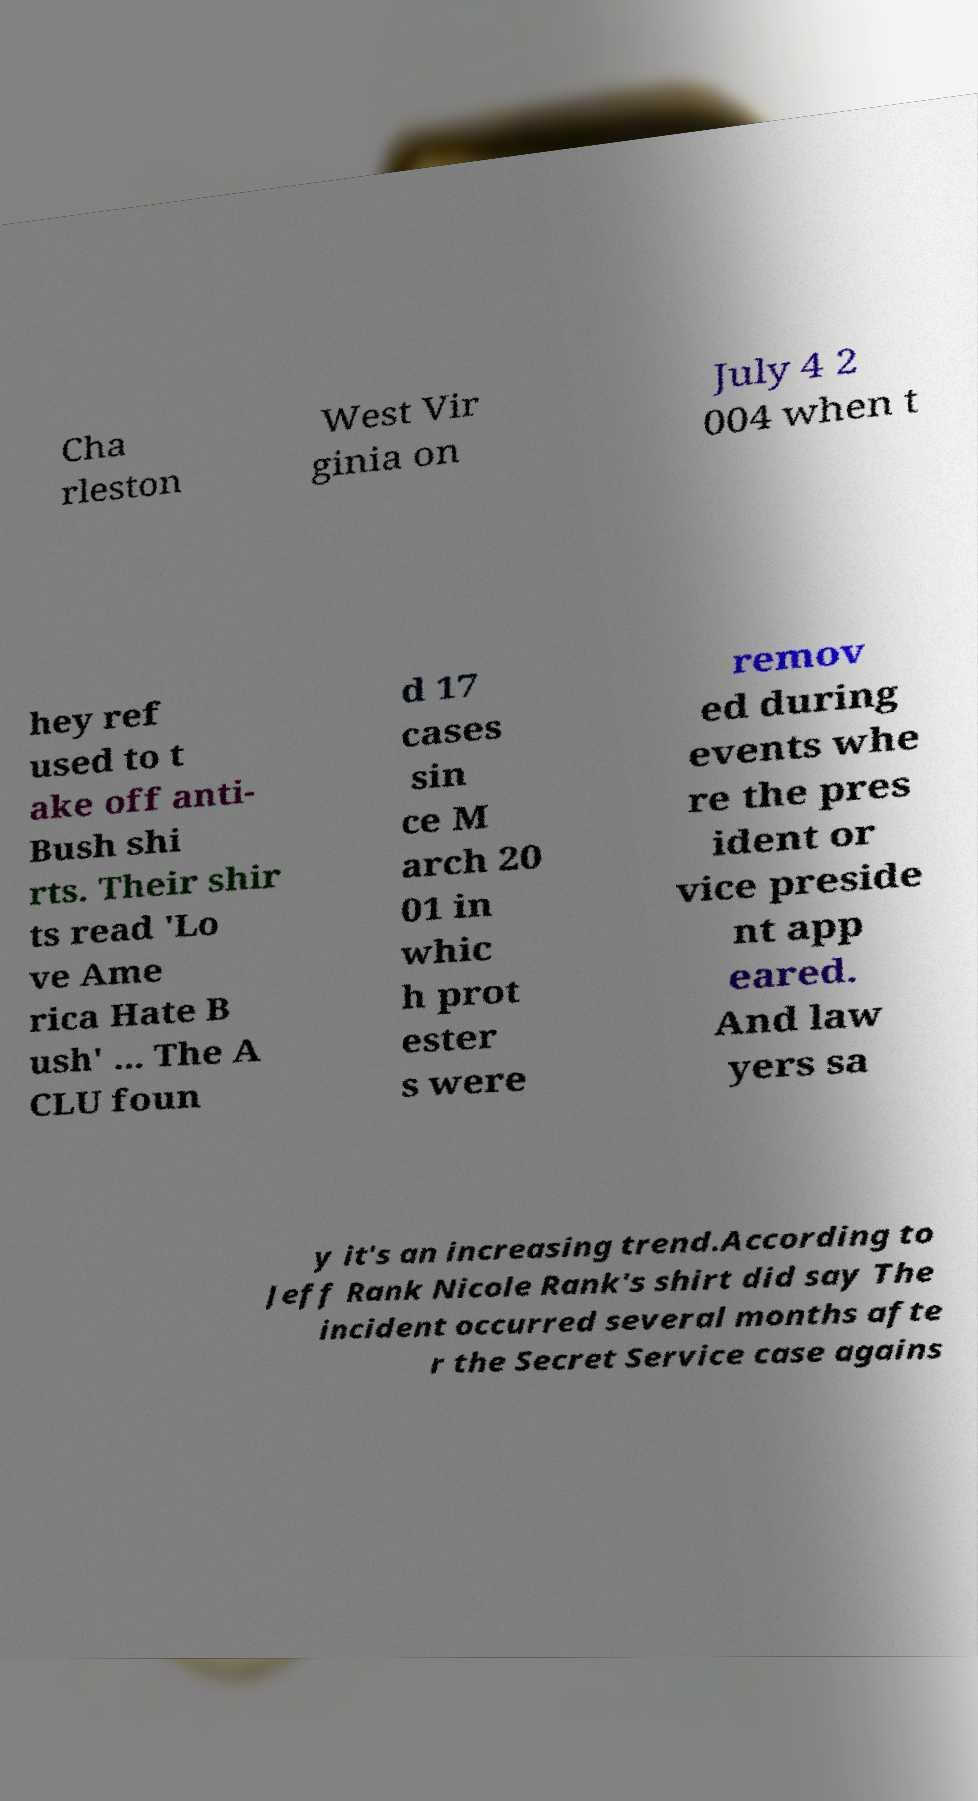What messages or text are displayed in this image? I need them in a readable, typed format. Cha rleston West Vir ginia on July 4 2 004 when t hey ref used to t ake off anti- Bush shi rts. Their shir ts read 'Lo ve Ame rica Hate B ush' ... The A CLU foun d 17 cases sin ce M arch 20 01 in whic h prot ester s were remov ed during events whe re the pres ident or vice preside nt app eared. And law yers sa y it's an increasing trend.According to Jeff Rank Nicole Rank's shirt did say The incident occurred several months afte r the Secret Service case agains 